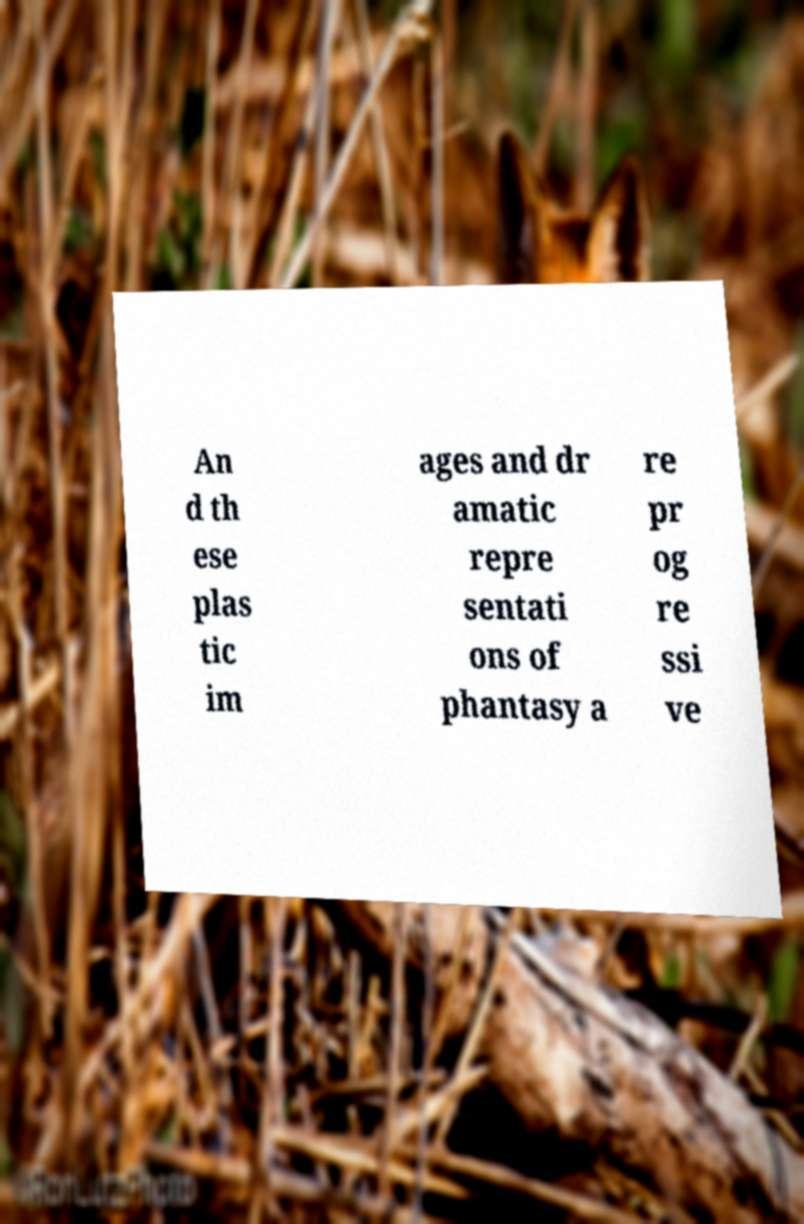Could you extract and type out the text from this image? An d th ese plas tic im ages and dr amatic repre sentati ons of phantasy a re pr og re ssi ve 